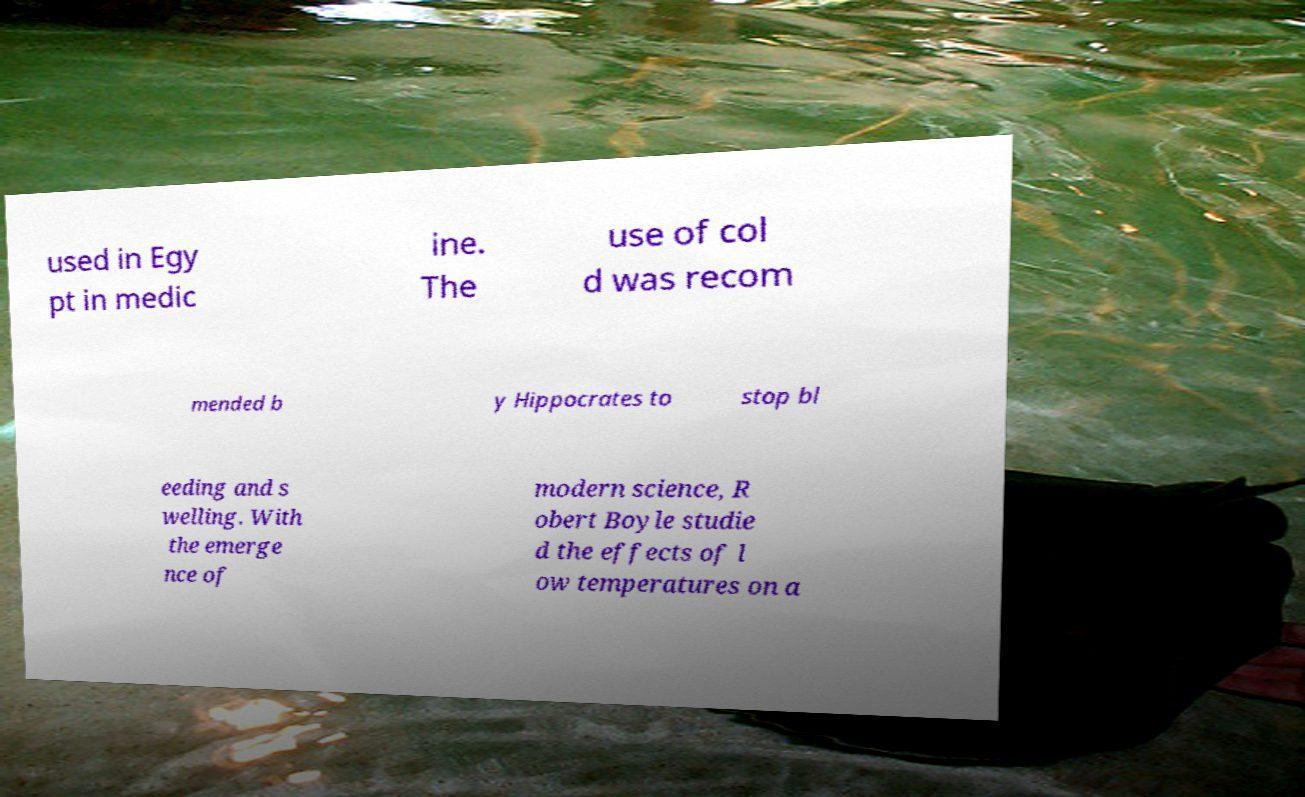Could you assist in decoding the text presented in this image and type it out clearly? used in Egy pt in medic ine. The use of col d was recom mended b y Hippocrates to stop bl eeding and s welling. With the emerge nce of modern science, R obert Boyle studie d the effects of l ow temperatures on a 